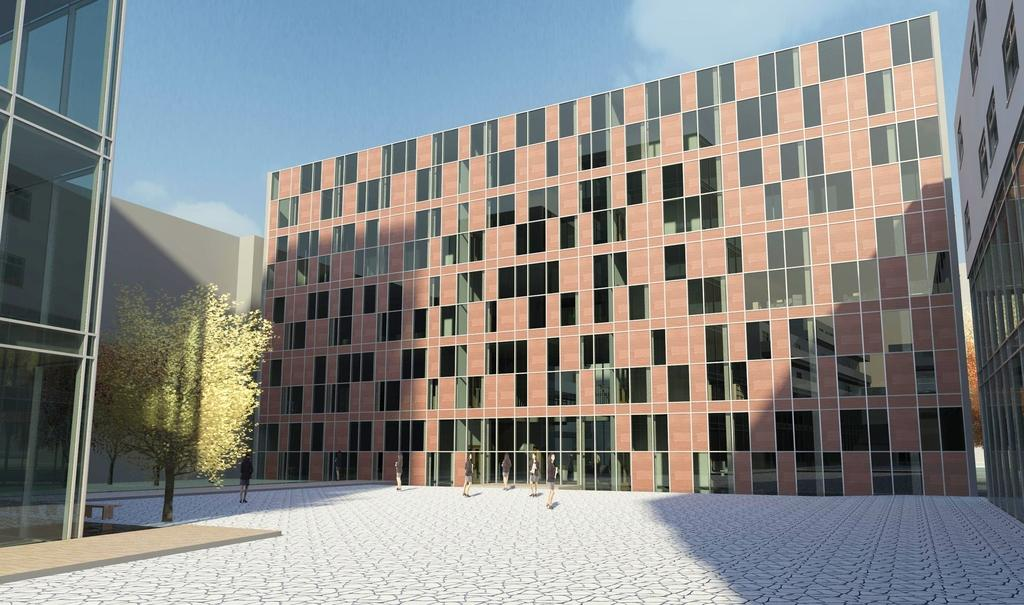What type of structures are present in the image? There are buildings in the image. What feature can be seen on the windows of the buildings? The windows of the buildings have glass. Can you describe the people visible in front of the buildings? There are people visible in front of the buildings. What is the surface in front of the buildings made of? There is a floor visible in front of the buildings. What type of vegetation is present in front of the buildings? There is a tree visible in front of the buildings. What is visible at the top of the image? The sky is visible at the top of the image. Can you tell me how many ghosts are visible in front of the buildings? There are no ghosts visible in front of the buildings; only people, a floor, a tree, and the sky are present. What type of store can be seen in the image? There is no store present in the image; it features buildings, people, a floor, a tree, and the sky. 